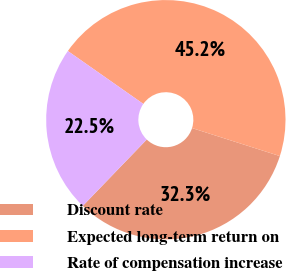Convert chart to OTSL. <chart><loc_0><loc_0><loc_500><loc_500><pie_chart><fcel>Discount rate<fcel>Expected long-term return on<fcel>Rate of compensation increase<nl><fcel>32.29%<fcel>45.18%<fcel>22.52%<nl></chart> 